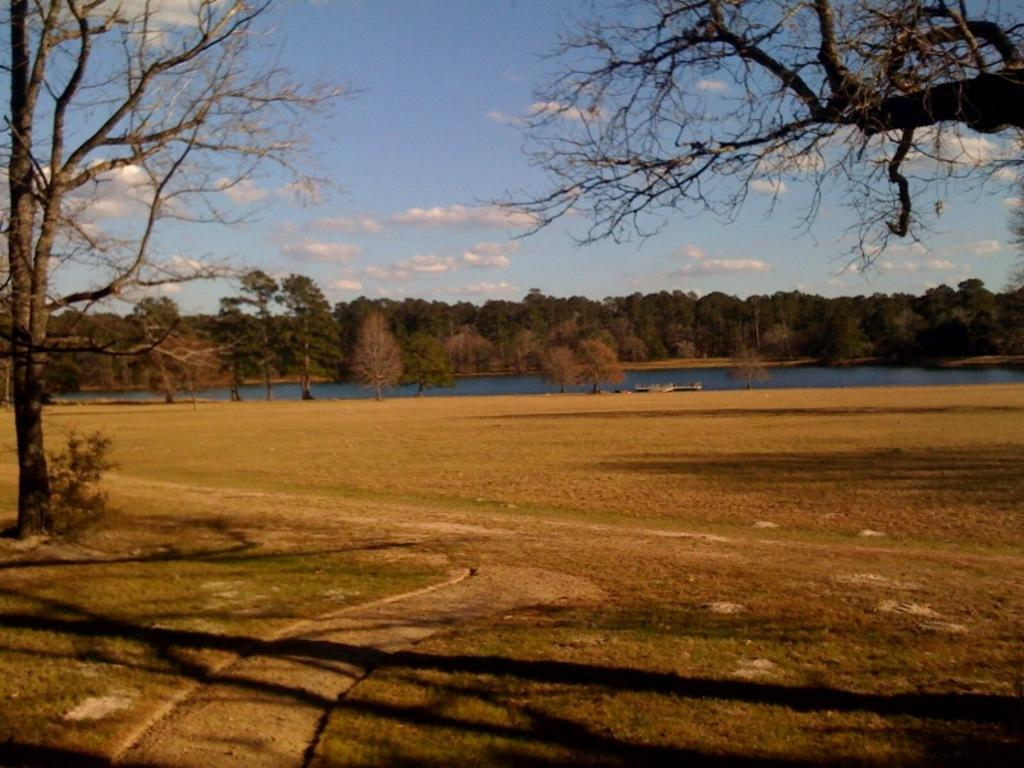What can be seen in the sky in the background of the image? There are clouds in the sky in the background of the image. What type of vegetation is present in the image? There are trees, plants, and grass in the image. What is visible in the image besides vegetation? There is water, ground, and sky visible in the image. Where is the gun located in the image? There is no gun present in the image. What type of coast can be seen in the image? There is no coast visible in the image. 